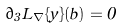Convert formula to latex. <formula><loc_0><loc_0><loc_500><loc_500>\partial _ { 3 } L _ { \nabla } \{ \hat { y } \} ( b ) = 0</formula> 